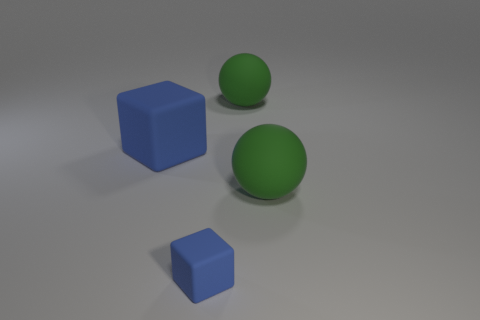There is a big block that is the same color as the small thing; what is its material?
Provide a succinct answer. Rubber. There is a big rubber thing on the left side of the thing that is behind the large matte cube; what shape is it?
Your answer should be compact. Cube. How many other objects are the same material as the big block?
Keep it short and to the point. 3. Is the number of tiny blue matte things greater than the number of matte cubes?
Provide a short and direct response. No. What size is the rubber block in front of the green matte sphere in front of the blue matte block behind the small matte block?
Provide a succinct answer. Small. Are there fewer blue rubber things that are left of the big blue rubber thing than cyan metallic balls?
Your answer should be very brief. No. How many big matte balls have the same color as the small matte cube?
Give a very brief answer. 0. Are there fewer small blue rubber cylinders than large rubber cubes?
Provide a succinct answer. Yes. There is a block left of the blue rubber object in front of the large blue rubber thing; what is its color?
Ensure brevity in your answer.  Blue. Are there any large objects made of the same material as the small blue block?
Provide a succinct answer. Yes. 